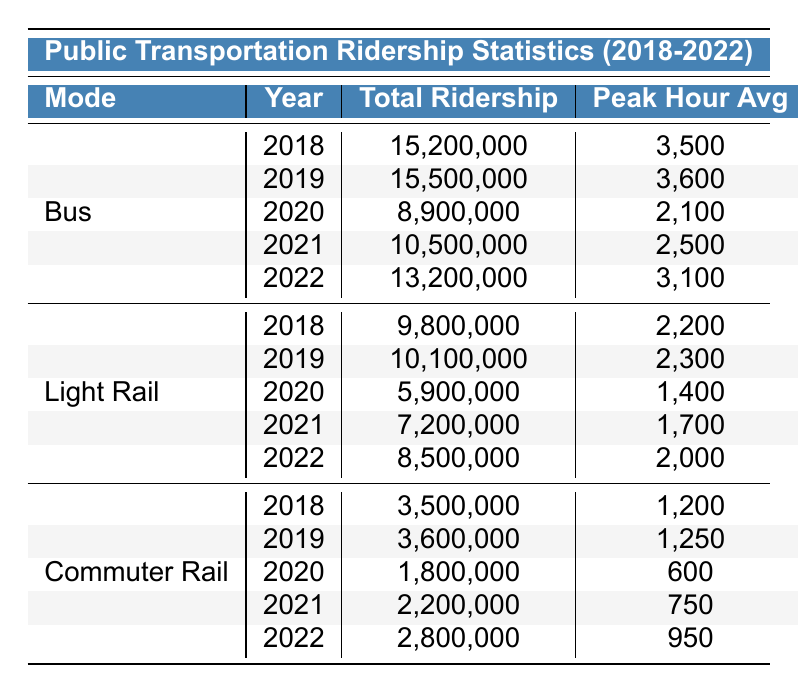What was the total ridership for buses in 2020? According to the table, the total ridership for buses in 2020 is listed as 8,900,000.
Answer: 8,900,000 How much did bus ridership increase from 2018 to 2019? The bus ridership increased from 15,200,000 in 2018 to 15,500,000 in 2019. The difference is 15,500,000 - 15,200,000 = 300,000.
Answer: 300,000 In which year did Light Rail see the highest total ridership? Looking through the values for Light Rail, the highest total ridership was 10,100,000 in 2019.
Answer: 2019 What was the average total ridership for Commuter Rail over the 5-year period? The total ridership for Commuter Rail from 2018 to 2022 is 3,500,000, 3,600,000, 1,800,000, 2,200,000, and 2,800,000. Summing these gives 14,900,000. Dividing by 5 for the average gives 14,900,000 / 5 = 2,980,000.
Answer: 2,980,000 Did the Off-Peak Hour Average for buses increase or decrease from 2018 to 2022? In 2018, the Off-Peak Hour Average for buses was 1,200 and in 2022 it was 1,100, showing a decrease: 1,100 < 1,200.
Answer: Decrease What is the total ridership for Light Rail in 2021 and 2022 combined? The total ridership for Light Rail is 7,200,000 in 2021 and 8,500,000 in 2022. The combined total is 7,200,000 + 8,500,000 = 15,700,000.
Answer: 15,700,000 Which mode of transportation had the lowest peak hour average in 2020? By checking the Peak Hour Average, Commuter Rail had the lowest at 600 in 2020 compared to the other modes.
Answer: Commuter Rail What was the percentage increase in total bus ridership from 2021 to 2022? Bus ridership increased from 10,500,000 in 2021 to 13,200,000 in 2022. The increase is 13,200,000 - 10,500,000 = 2,700,000. The percentage increase is (2,700,000 / 10,500,000) × 100 ≈ 25.71%.
Answer: Approximately 25.71% Was the total ridership for Light Rail in 2020 greater than that of Commuter Rail in the same year? In 2020, Light Rail had a total ridership of 5,900,000 and Commuter Rail had 1,800,000. Since 5,900,000 > 1,800,000, the statement is true.
Answer: Yes Which year saw the highest peak hour average for any mode of transportation? The highest peak hour average recorded was 3,600 in 2019 for buses.
Answer: 2019 